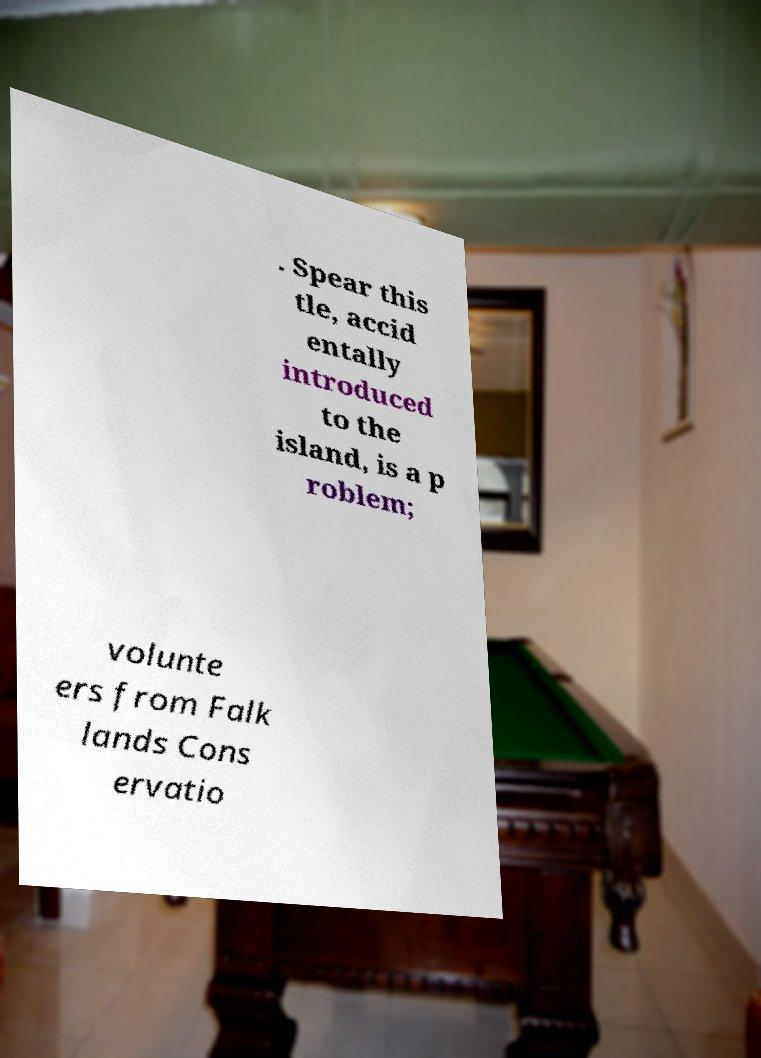Can you accurately transcribe the text from the provided image for me? . Spear this tle, accid entally introduced to the island, is a p roblem; volunte ers from Falk lands Cons ervatio 